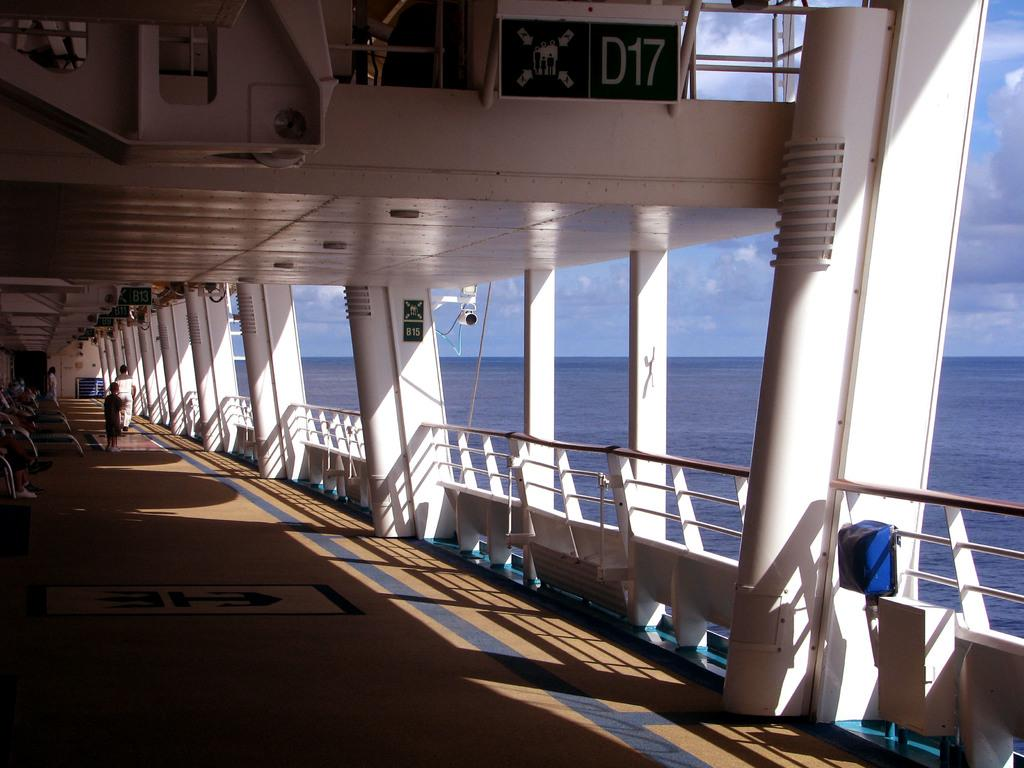What is the main subject of the image? The main subject of the image is a ship. Are there any people on the ship? Yes, there are people in the ship. What can be seen on the right side of the image? There is water on the right side of the image. What is visible in the background of the image? The sky is visible in the background of the image. What type of cave can be seen on the ship in the image? There is no cave present on the ship in the image. What material is the roof of the ship made of? The image does not provide information about the roof of the ship or its material. 